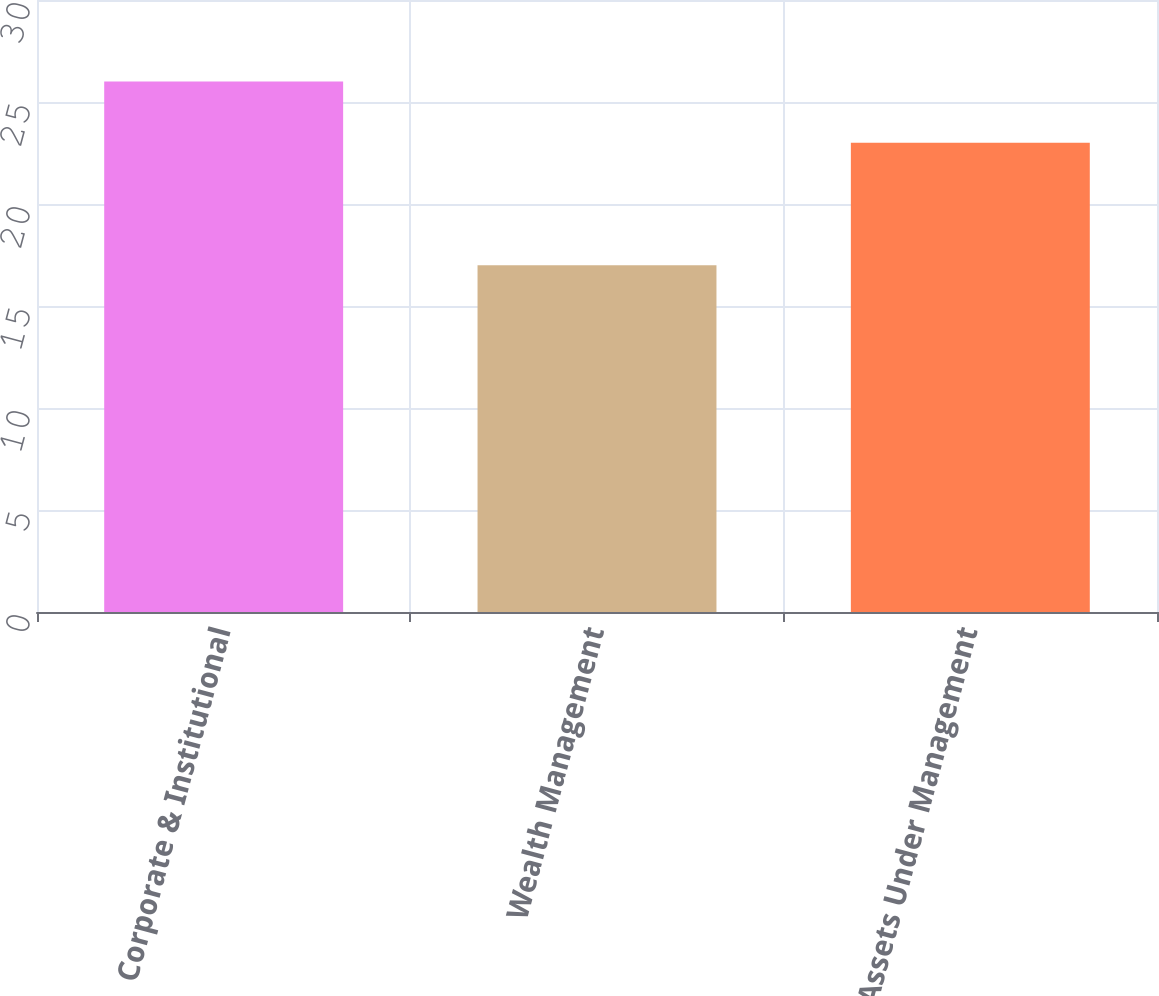Convert chart. <chart><loc_0><loc_0><loc_500><loc_500><bar_chart><fcel>Corporate & Institutional<fcel>Wealth Management<fcel>Total Assets Under Management<nl><fcel>26<fcel>17<fcel>23<nl></chart> 